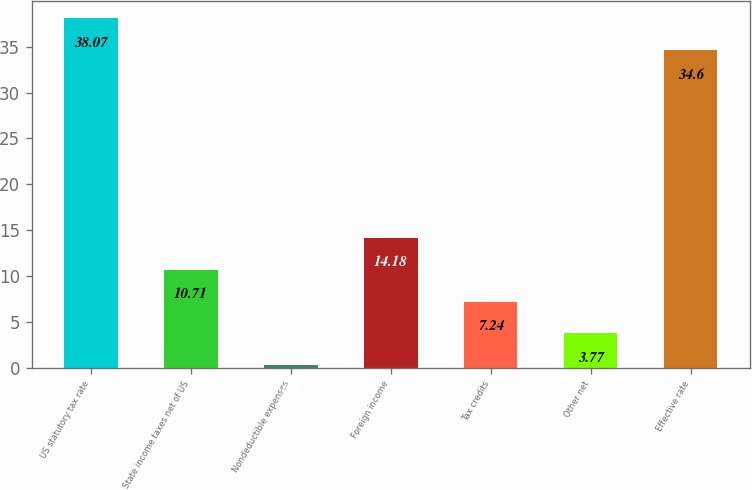Convert chart to OTSL. <chart><loc_0><loc_0><loc_500><loc_500><bar_chart><fcel>US statutory tax rate<fcel>State income taxes net of US<fcel>Nondeductible expenses<fcel>Foreign income<fcel>Tax credits<fcel>Other net<fcel>Effective rate<nl><fcel>38.07<fcel>10.71<fcel>0.3<fcel>14.18<fcel>7.24<fcel>3.77<fcel>34.6<nl></chart> 